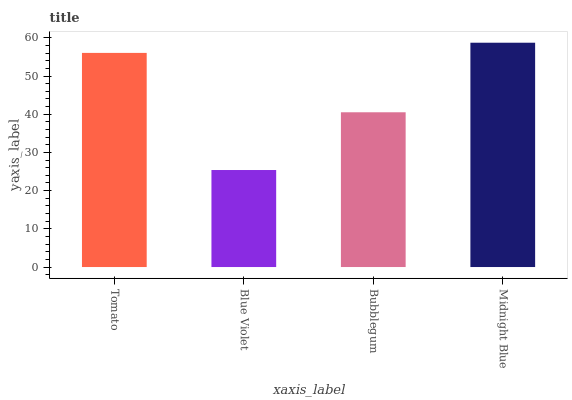Is Bubblegum the minimum?
Answer yes or no. No. Is Bubblegum the maximum?
Answer yes or no. No. Is Bubblegum greater than Blue Violet?
Answer yes or no. Yes. Is Blue Violet less than Bubblegum?
Answer yes or no. Yes. Is Blue Violet greater than Bubblegum?
Answer yes or no. No. Is Bubblegum less than Blue Violet?
Answer yes or no. No. Is Tomato the high median?
Answer yes or no. Yes. Is Bubblegum the low median?
Answer yes or no. Yes. Is Bubblegum the high median?
Answer yes or no. No. Is Midnight Blue the low median?
Answer yes or no. No. 